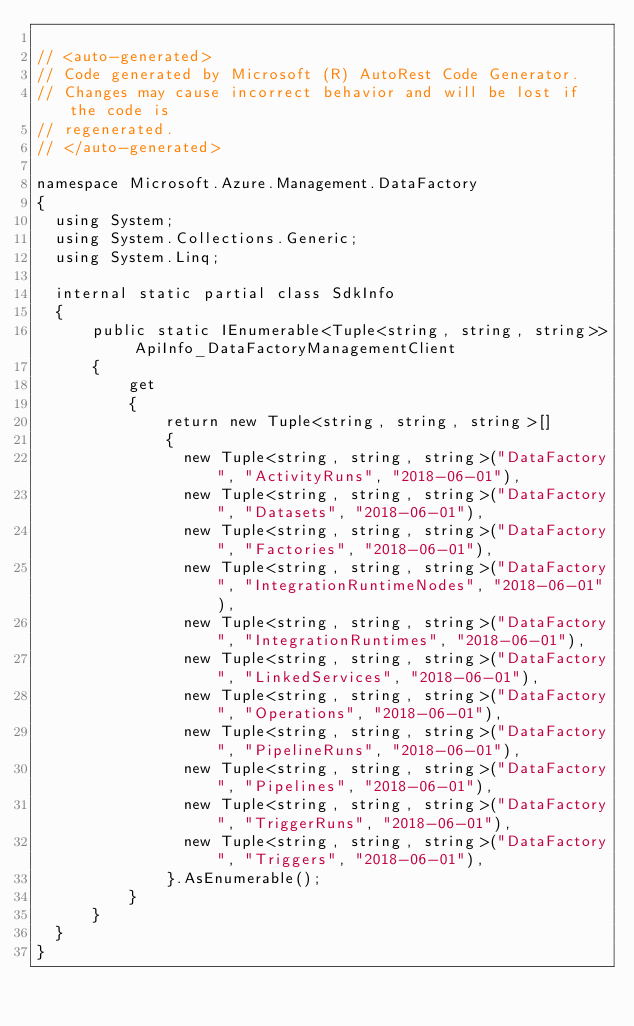Convert code to text. <code><loc_0><loc_0><loc_500><loc_500><_C#_>
// <auto-generated>
// Code generated by Microsoft (R) AutoRest Code Generator.
// Changes may cause incorrect behavior and will be lost if the code is
// regenerated.
// </auto-generated>

namespace Microsoft.Azure.Management.DataFactory
{
  using System;
  using System.Collections.Generic;
  using System.Linq;

  internal static partial class SdkInfo
  {
      public static IEnumerable<Tuple<string, string, string>> ApiInfo_DataFactoryManagementClient
      {
          get
          {
              return new Tuple<string, string, string>[]
              {
                new Tuple<string, string, string>("DataFactory", "ActivityRuns", "2018-06-01"),
                new Tuple<string, string, string>("DataFactory", "Datasets", "2018-06-01"),
                new Tuple<string, string, string>("DataFactory", "Factories", "2018-06-01"),
                new Tuple<string, string, string>("DataFactory", "IntegrationRuntimeNodes", "2018-06-01"),
                new Tuple<string, string, string>("DataFactory", "IntegrationRuntimes", "2018-06-01"),
                new Tuple<string, string, string>("DataFactory", "LinkedServices", "2018-06-01"),
                new Tuple<string, string, string>("DataFactory", "Operations", "2018-06-01"),
                new Tuple<string, string, string>("DataFactory", "PipelineRuns", "2018-06-01"),
                new Tuple<string, string, string>("DataFactory", "Pipelines", "2018-06-01"),
                new Tuple<string, string, string>("DataFactory", "TriggerRuns", "2018-06-01"),
                new Tuple<string, string, string>("DataFactory", "Triggers", "2018-06-01"),
              }.AsEnumerable();
          }
      }
  }
}
</code> 